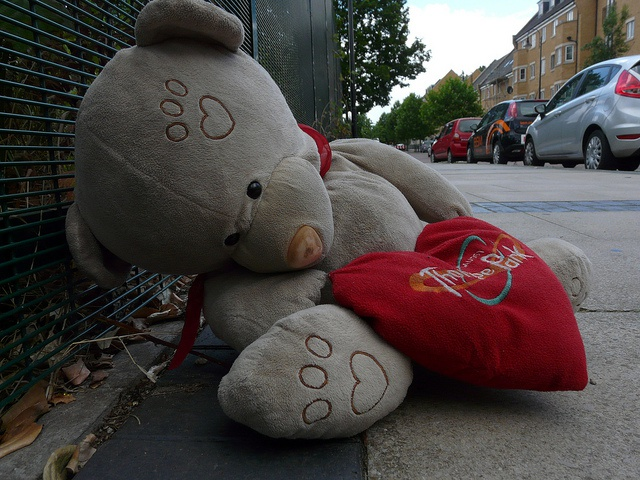Describe the objects in this image and their specific colors. I can see teddy bear in black, gray, and maroon tones, car in black and gray tones, car in black, gray, maroon, and purple tones, car in black, maroon, gray, and brown tones, and car in black, gray, and purple tones in this image. 